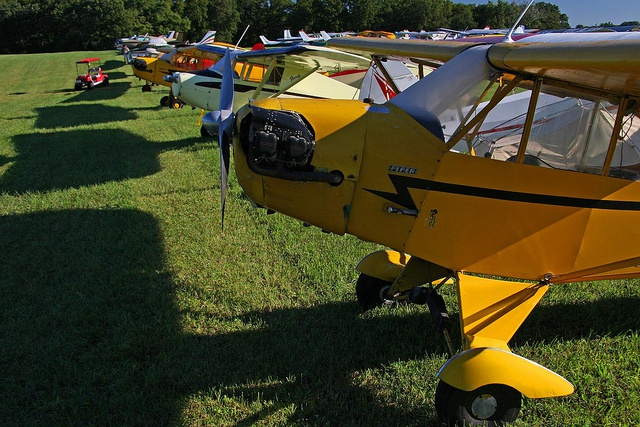Describe the objects in this image and their specific colors. I can see airplane in darkgreen, black, maroon, gray, and olive tones, airplane in darkgreen, teal, black, and orange tones, airplane in darkgreen, maroon, black, olive, and gray tones, airplane in darkgreen, black, darkgray, gray, and tan tones, and people in darkgreen, gray, and black tones in this image. 